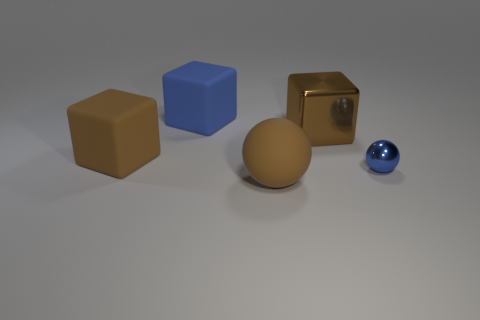Are there any other things that are the same size as the blue cube?
Ensure brevity in your answer.  Yes. There is a sphere that is left of the metallic object that is behind the blue metallic sphere; what is its material?
Make the answer very short. Rubber. What number of metallic things are either brown cylinders or brown blocks?
Offer a terse response. 1. There is another object that is the same shape as the tiny object; what is its color?
Provide a short and direct response. Brown. What number of large shiny things are the same color as the large matte sphere?
Offer a terse response. 1. Are there any large blue cubes that are left of the brown matte thing that is behind the big brown matte ball?
Your answer should be compact. No. How many things are both on the right side of the blue matte cube and in front of the brown metallic cube?
Give a very brief answer. 2. What number of large cyan objects have the same material as the small blue sphere?
Make the answer very short. 0. There is a matte block behind the large rubber block that is on the left side of the blue rubber cube; what size is it?
Keep it short and to the point. Large. Is there a tiny cyan matte object of the same shape as the big metallic object?
Ensure brevity in your answer.  No. 